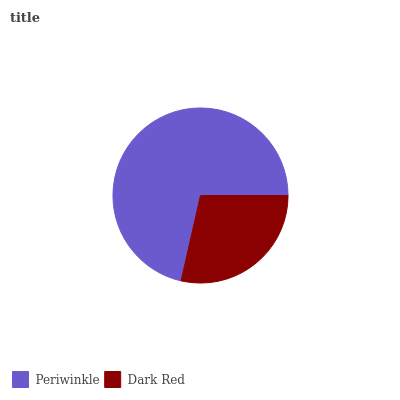Is Dark Red the minimum?
Answer yes or no. Yes. Is Periwinkle the maximum?
Answer yes or no. Yes. Is Dark Red the maximum?
Answer yes or no. No. Is Periwinkle greater than Dark Red?
Answer yes or no. Yes. Is Dark Red less than Periwinkle?
Answer yes or no. Yes. Is Dark Red greater than Periwinkle?
Answer yes or no. No. Is Periwinkle less than Dark Red?
Answer yes or no. No. Is Periwinkle the high median?
Answer yes or no. Yes. Is Dark Red the low median?
Answer yes or no. Yes. Is Dark Red the high median?
Answer yes or no. No. Is Periwinkle the low median?
Answer yes or no. No. 